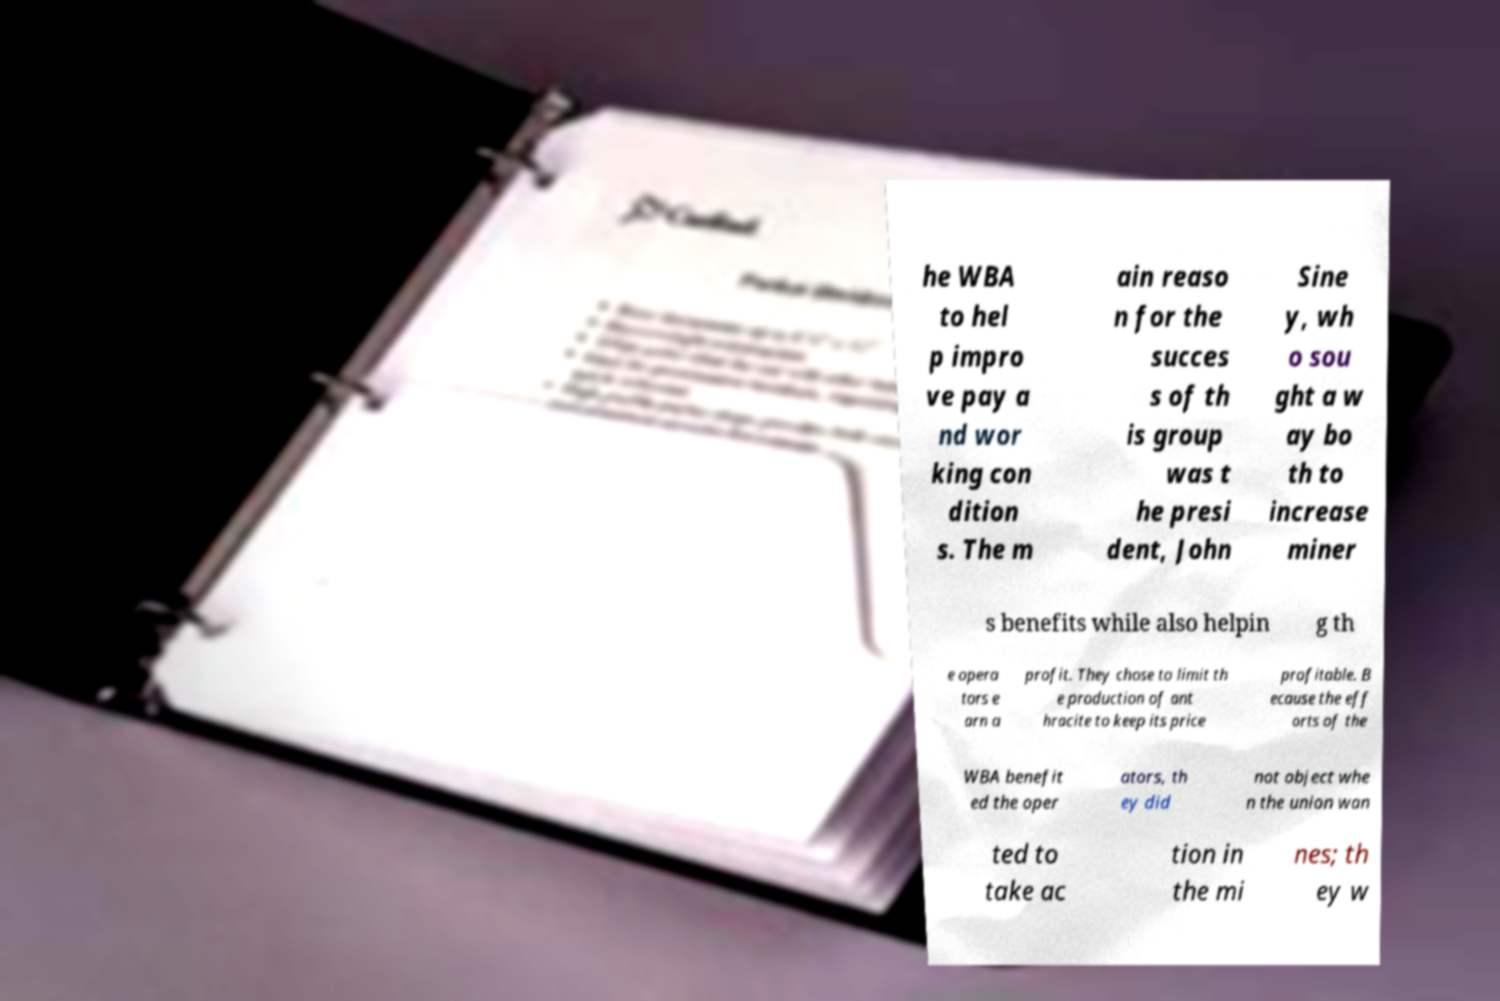There's text embedded in this image that I need extracted. Can you transcribe it verbatim? he WBA to hel p impro ve pay a nd wor king con dition s. The m ain reaso n for the succes s of th is group was t he presi dent, John Sine y, wh o sou ght a w ay bo th to increase miner s benefits while also helpin g th e opera tors e arn a profit. They chose to limit th e production of ant hracite to keep its price profitable. B ecause the eff orts of the WBA benefit ed the oper ators, th ey did not object whe n the union wan ted to take ac tion in the mi nes; th ey w 